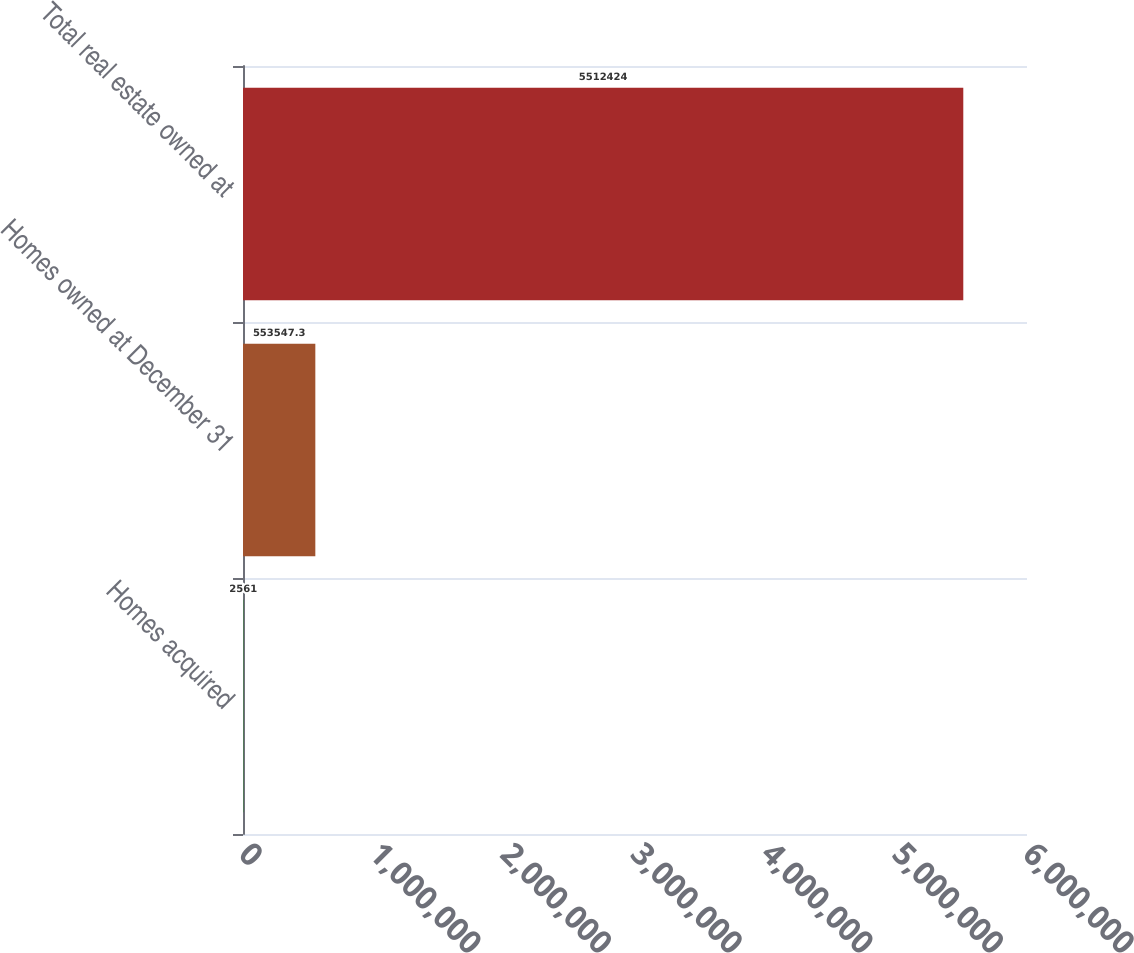<chart> <loc_0><loc_0><loc_500><loc_500><bar_chart><fcel>Homes acquired<fcel>Homes owned at December 31<fcel>Total real estate owned at<nl><fcel>2561<fcel>553547<fcel>5.51242e+06<nl></chart> 